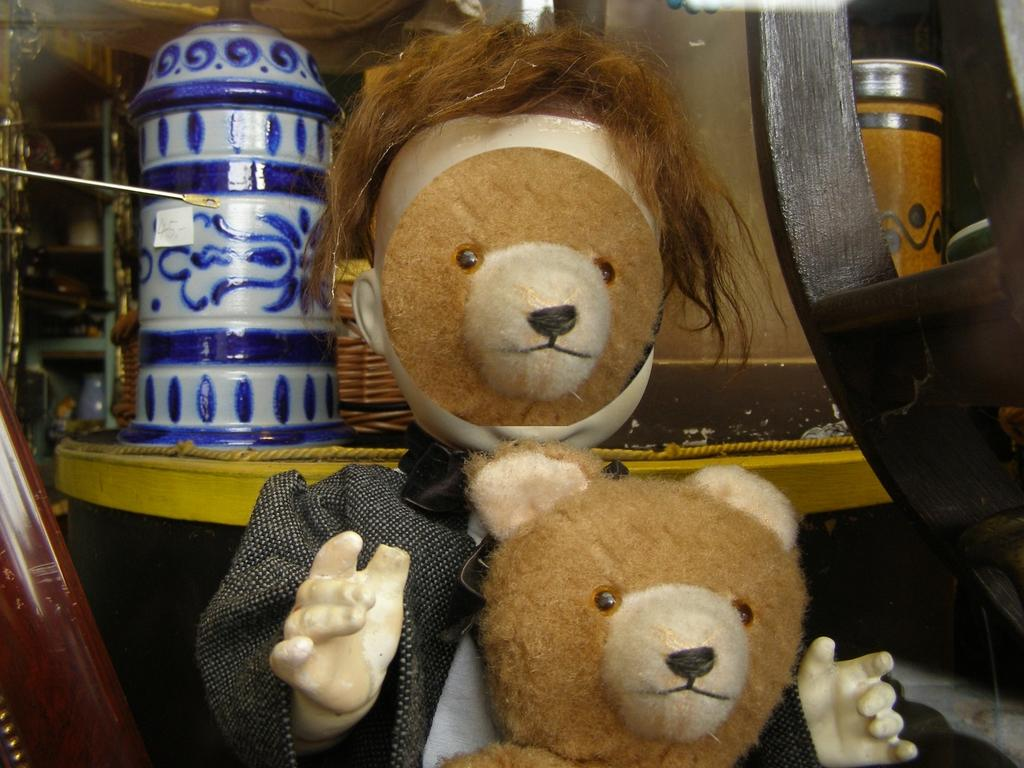How many teddies are present in the image? There are two teddies in the image. What can be seen in the background of the image? In the background of the image, there is a rope, a basket, and other unspecified things. Can you describe the rope in the background? The rope is visible in the background, but no further details about its appearance or use are provided. What type of flowers are being used as bait in the image? There are no flowers or bait present in the image. 